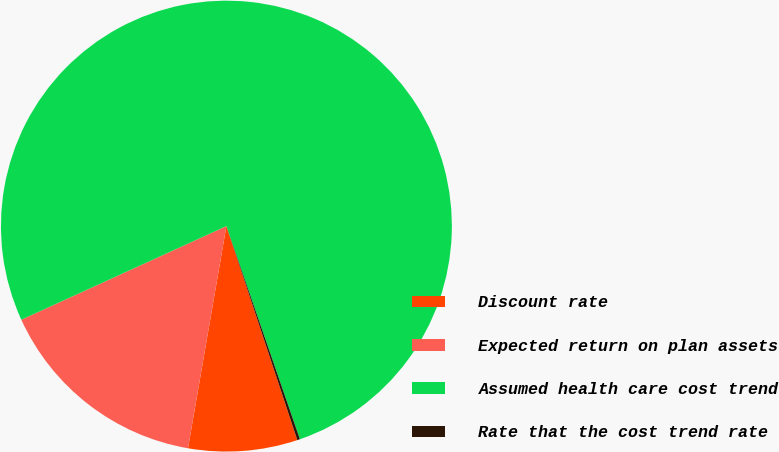Convert chart. <chart><loc_0><loc_0><loc_500><loc_500><pie_chart><fcel>Discount rate<fcel>Expected return on plan assets<fcel>Assumed health care cost trend<fcel>Rate that the cost trend rate<nl><fcel>7.82%<fcel>15.46%<fcel>76.53%<fcel>0.19%<nl></chart> 